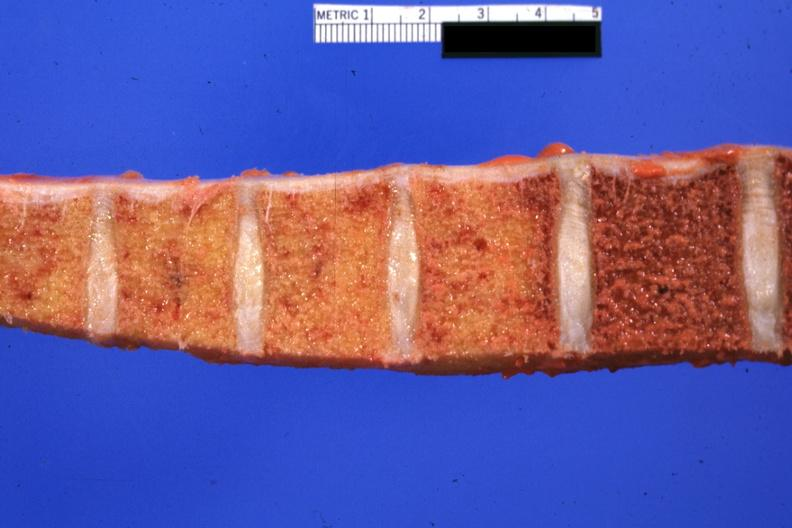what does this image show?
Answer the question using a single word or phrase. Vertebral column with obvious fibrosis involving four of the bodies but not the remaining one in photo cause of lesion not proved but almost certainly due to radiation for lung carcinoma and meningeal carcinomatosis 